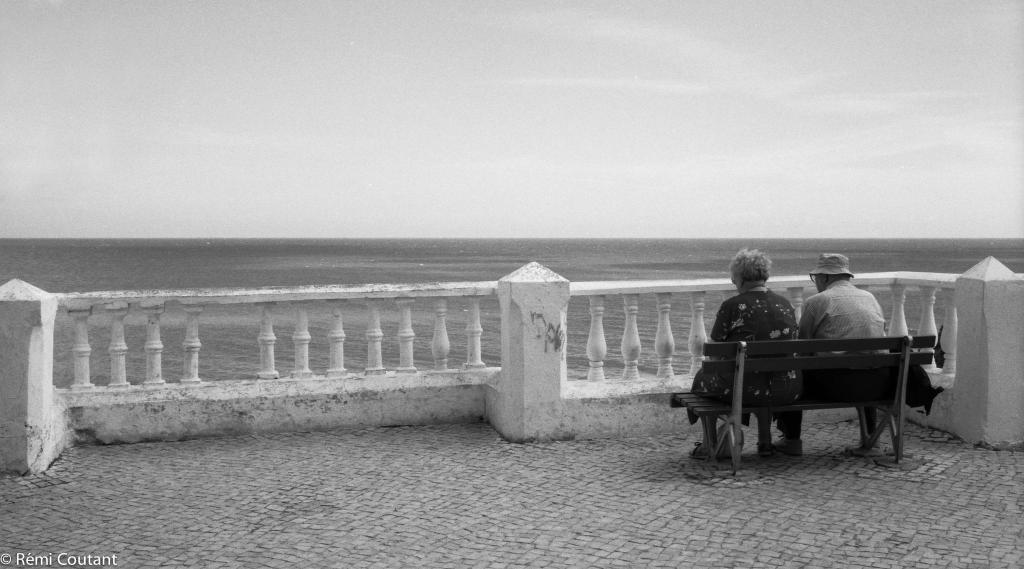How would you summarize this image in a sentence or two? A lady and a man wearing hat is sitting on a bench. There are railings. In the background, there is sky and water. 